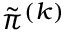Convert formula to latex. <formula><loc_0><loc_0><loc_500><loc_500>\tilde { \pi } ^ { ( k ) }</formula> 